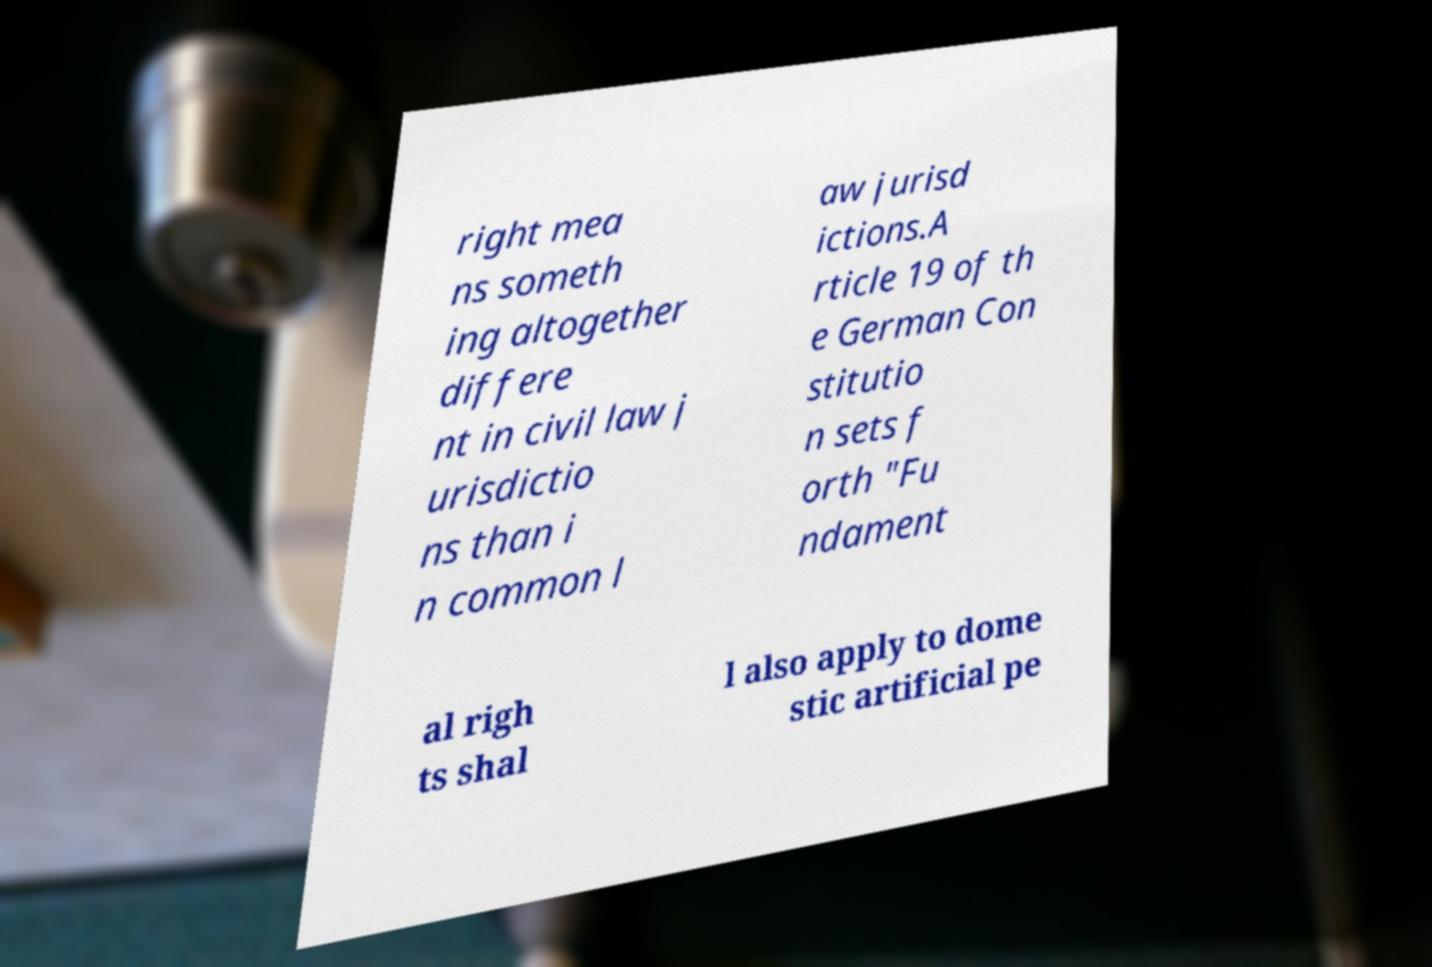Can you accurately transcribe the text from the provided image for me? right mea ns someth ing altogether differe nt in civil law j urisdictio ns than i n common l aw jurisd ictions.A rticle 19 of th e German Con stitutio n sets f orth "Fu ndament al righ ts shal l also apply to dome stic artificial pe 